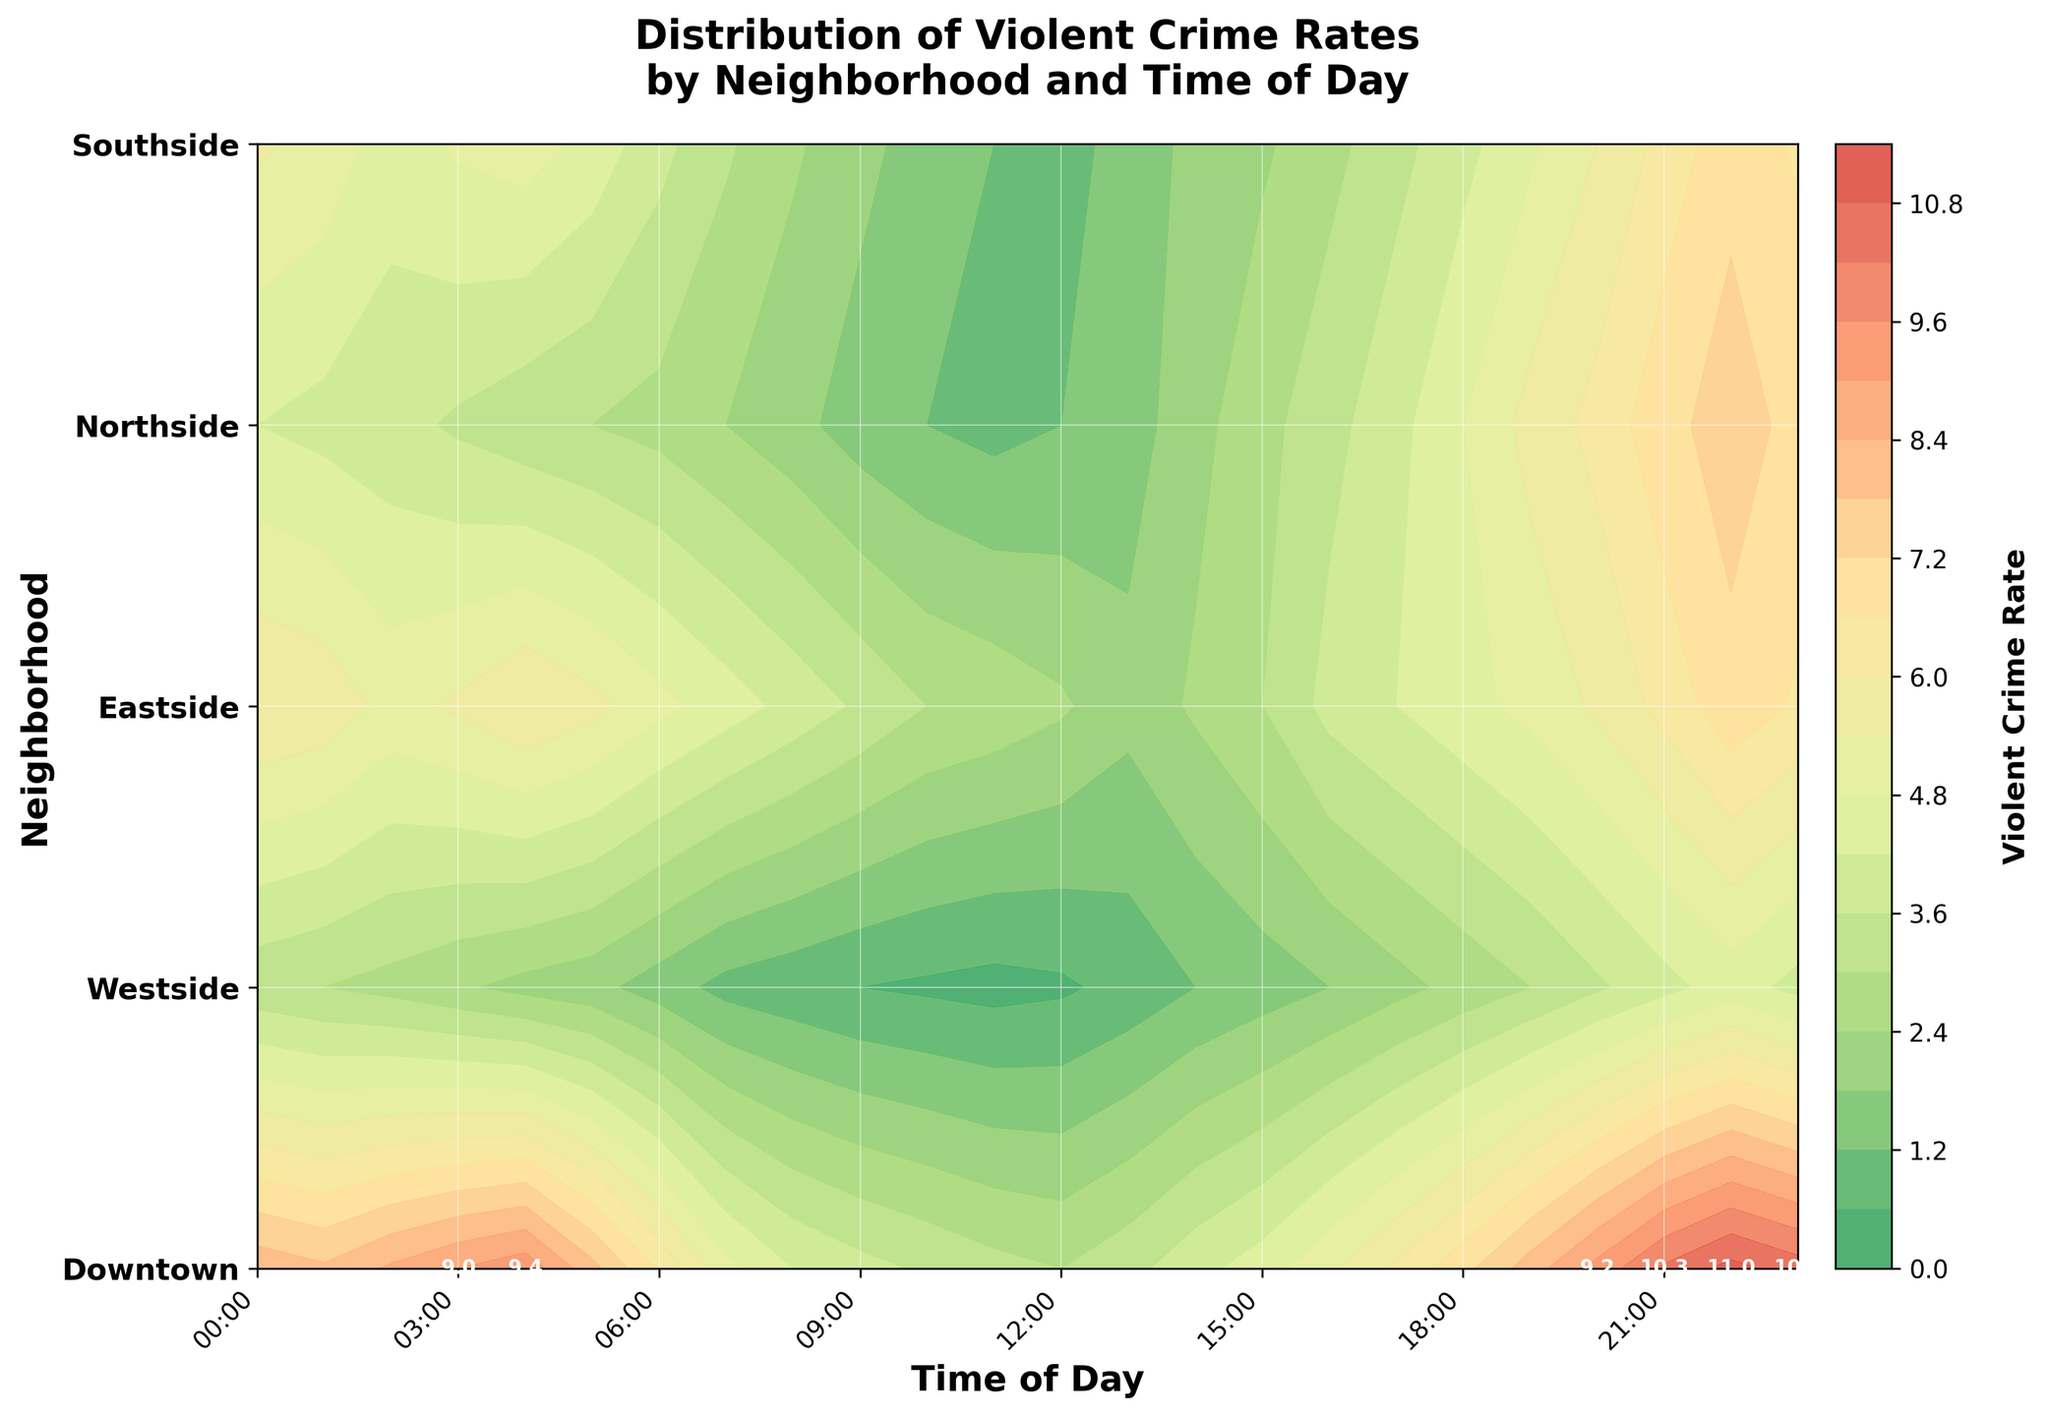What's the title of the figure? The title of the figure is located at the top and it's typically in a larger font size to indicate the main topic the graph addresses.
Answer: Distribution of Violent Crime Rates by Neighborhood and Time of Day How are the neighborhoods labeled on the plot? The neighborhoods are labeled along the y-axis of the plot, with each neighborhood corresponding to a specific row. The labels are bold and placed to the left of the plot.
Answer: Downtown, Westside, Eastside, Northside, Southside What does the color bar represent? The color bar is usually placed alongside the plot and provides a scale for interpreting the colors within the contour plot. It indicates the range of violent crime rates.
Answer: Violent Crime Rate Which neighborhood has the lowest violent crime rate during the midday (12:00) period? To find the lowest crime rate during midday, locate the 12:00 hour on the x-axis and compare the values in the middle of the y-axis for each neighborhood.
Answer: Eastside Which time of day in Downtown shows the peak violent crime rate? Locate the Downtown row on the y-axis and scan horizontally to find the hour with the highest value, indicated by the deepest red color in the contour plot.
Answer: 22:00 At what hour does Westside have its highest violent crime rate? Check the Westside row on the y-axis and compare the values across the different hours to find the peak, marked by the darkest color within that row.
Answer: 22:00 Which neighborhood shows the most significant increase in violent crime rate from midnight to 3 AM? By comparing the rates from 0 to 3 hours across the neighborhoods, identify the one with the largest increase, visible as a sharp change in color in the plot.
Answer: Downtown Between Northside and Southside, which sees a higher violent crime rate at 21:00? Look at the 21:00 hour on the x-axis and trace upwards to the Northside and Southside rows to compare their values. The neighborhood with the darker color (higher rate) is the answer.
Answer: Northside When does Eastside show an increase in violent crime rates? By examining the Eastside row, identify the hours where there's a clear change from a lighter to darker color trend, indicating a rise in violent crime rates.
Answer: 17:00 to 22:00 How do the violent crime rates at 6:00 compare across all neighborhoods? Find the 6:00 hour on the x-axis and move vertically through all neighborhoods to see and compare the shades of colors represented in that column, with darker shades indicating higher crime rates.
Answer: Downtown > Northside > Westside > Southside > Eastside 